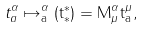<formula> <loc_0><loc_0><loc_500><loc_500>t ^ { \alpha } _ { a } \mapsto \tt ^ { \alpha } _ { a } ( t ^ { * } _ { * } ) = M ^ { \alpha } _ { \mu } t ^ { \mu } _ { a } ,</formula> 